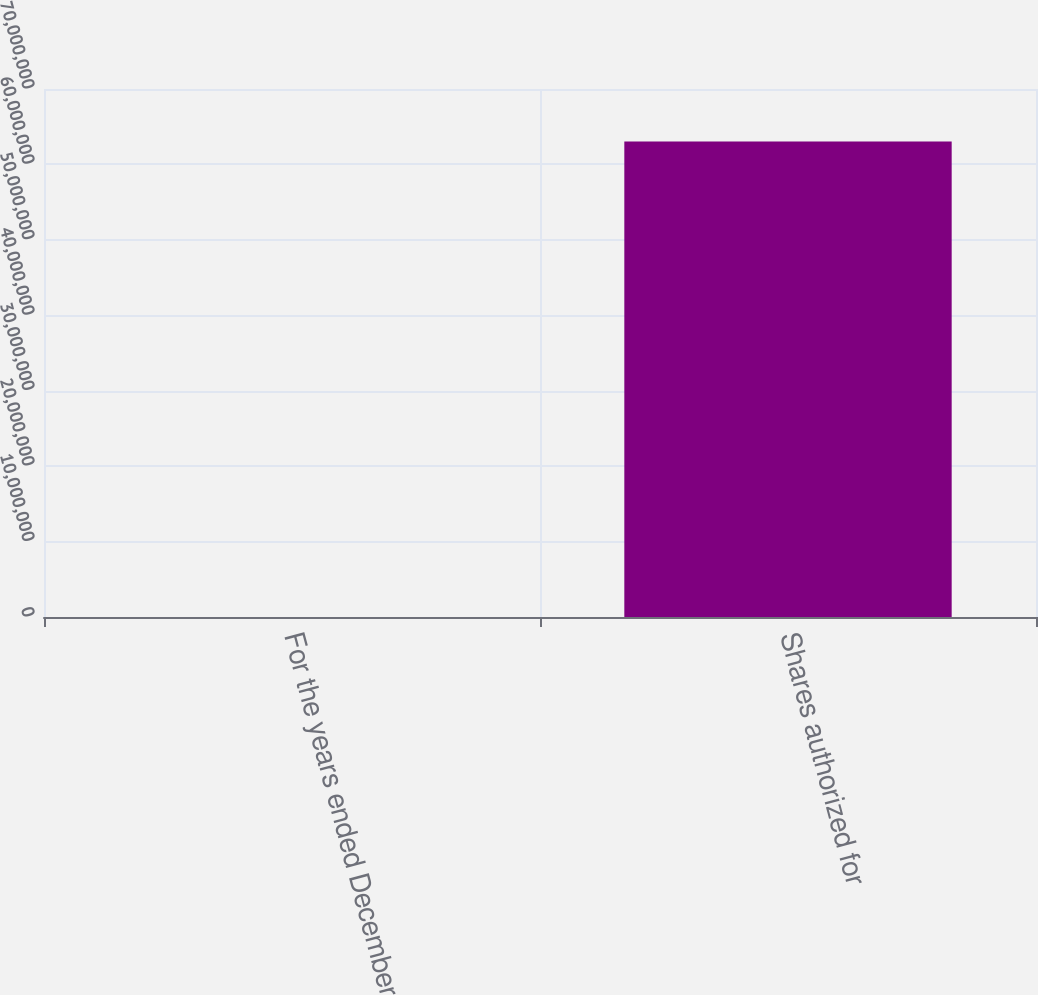<chart> <loc_0><loc_0><loc_500><loc_500><bar_chart><fcel>For the years ended December<fcel>Shares authorized for<nl><fcel>2012<fcel>6.30467e+07<nl></chart> 